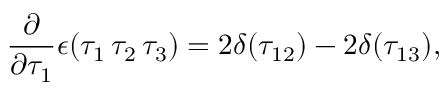<formula> <loc_0><loc_0><loc_500><loc_500>\frac { \partial } { \partial \tau _ { 1 } } \epsilon ( \tau _ { 1 } \, \tau _ { 2 } \, \tau _ { 3 } ) = 2 \delta ( \tau _ { 1 2 } ) - 2 \delta ( \tau _ { 1 3 } ) ,</formula> 